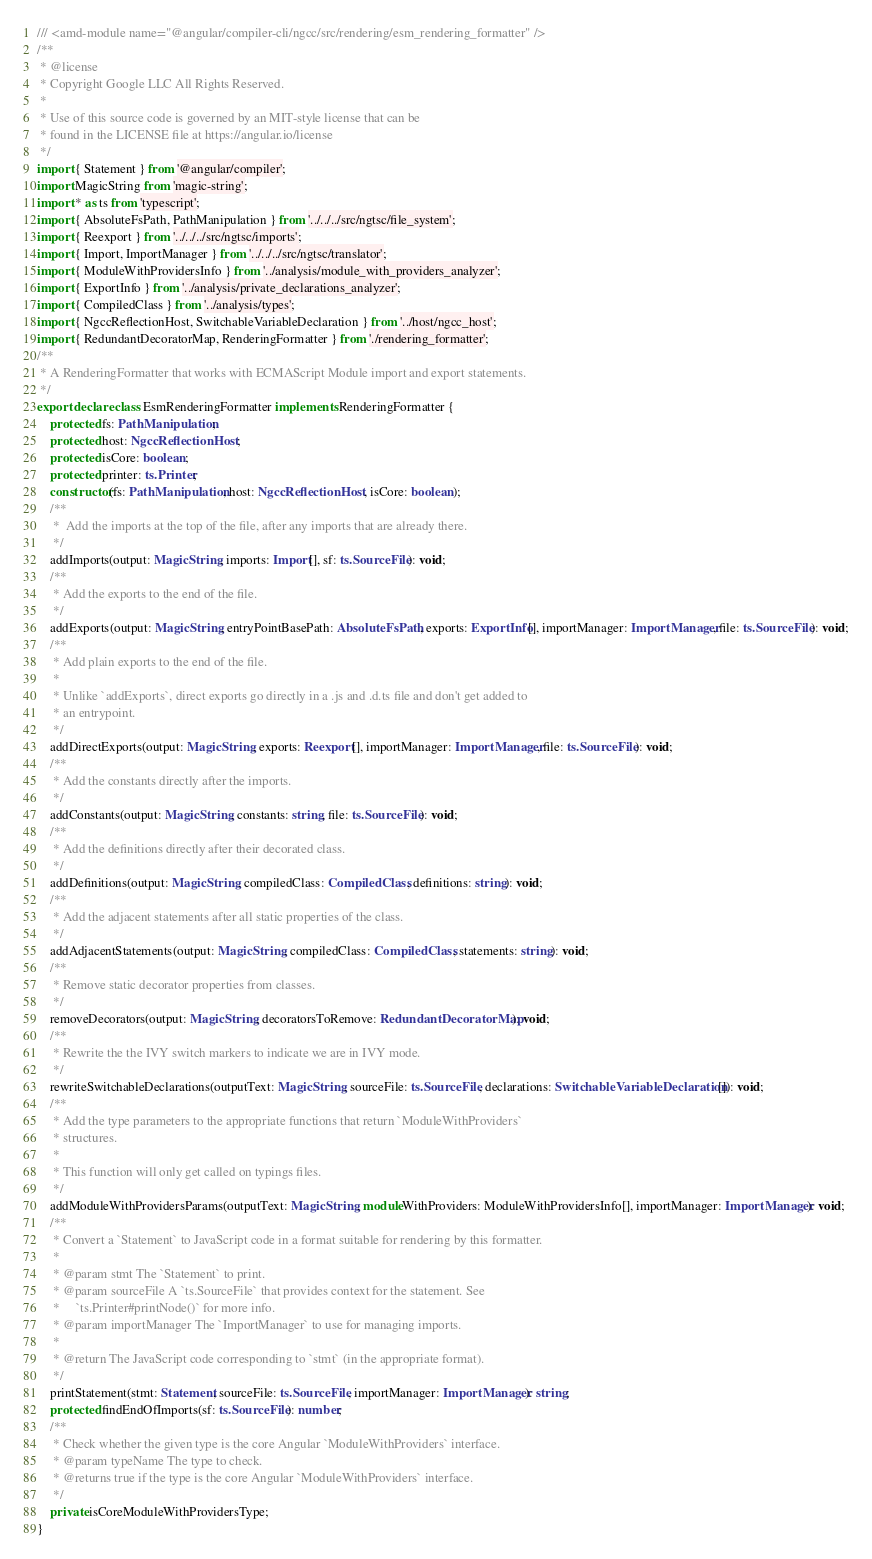<code> <loc_0><loc_0><loc_500><loc_500><_TypeScript_>/// <amd-module name="@angular/compiler-cli/ngcc/src/rendering/esm_rendering_formatter" />
/**
 * @license
 * Copyright Google LLC All Rights Reserved.
 *
 * Use of this source code is governed by an MIT-style license that can be
 * found in the LICENSE file at https://angular.io/license
 */
import { Statement } from '@angular/compiler';
import MagicString from 'magic-string';
import * as ts from 'typescript';
import { AbsoluteFsPath, PathManipulation } from '../../../src/ngtsc/file_system';
import { Reexport } from '../../../src/ngtsc/imports';
import { Import, ImportManager } from '../../../src/ngtsc/translator';
import { ModuleWithProvidersInfo } from '../analysis/module_with_providers_analyzer';
import { ExportInfo } from '../analysis/private_declarations_analyzer';
import { CompiledClass } from '../analysis/types';
import { NgccReflectionHost, SwitchableVariableDeclaration } from '../host/ngcc_host';
import { RedundantDecoratorMap, RenderingFormatter } from './rendering_formatter';
/**
 * A RenderingFormatter that works with ECMAScript Module import and export statements.
 */
export declare class EsmRenderingFormatter implements RenderingFormatter {
    protected fs: PathManipulation;
    protected host: NgccReflectionHost;
    protected isCore: boolean;
    protected printer: ts.Printer;
    constructor(fs: PathManipulation, host: NgccReflectionHost, isCore: boolean);
    /**
     *  Add the imports at the top of the file, after any imports that are already there.
     */
    addImports(output: MagicString, imports: Import[], sf: ts.SourceFile): void;
    /**
     * Add the exports to the end of the file.
     */
    addExports(output: MagicString, entryPointBasePath: AbsoluteFsPath, exports: ExportInfo[], importManager: ImportManager, file: ts.SourceFile): void;
    /**
     * Add plain exports to the end of the file.
     *
     * Unlike `addExports`, direct exports go directly in a .js and .d.ts file and don't get added to
     * an entrypoint.
     */
    addDirectExports(output: MagicString, exports: Reexport[], importManager: ImportManager, file: ts.SourceFile): void;
    /**
     * Add the constants directly after the imports.
     */
    addConstants(output: MagicString, constants: string, file: ts.SourceFile): void;
    /**
     * Add the definitions directly after their decorated class.
     */
    addDefinitions(output: MagicString, compiledClass: CompiledClass, definitions: string): void;
    /**
     * Add the adjacent statements after all static properties of the class.
     */
    addAdjacentStatements(output: MagicString, compiledClass: CompiledClass, statements: string): void;
    /**
     * Remove static decorator properties from classes.
     */
    removeDecorators(output: MagicString, decoratorsToRemove: RedundantDecoratorMap): void;
    /**
     * Rewrite the the IVY switch markers to indicate we are in IVY mode.
     */
    rewriteSwitchableDeclarations(outputText: MagicString, sourceFile: ts.SourceFile, declarations: SwitchableVariableDeclaration[]): void;
    /**
     * Add the type parameters to the appropriate functions that return `ModuleWithProviders`
     * structures.
     *
     * This function will only get called on typings files.
     */
    addModuleWithProvidersParams(outputText: MagicString, moduleWithProviders: ModuleWithProvidersInfo[], importManager: ImportManager): void;
    /**
     * Convert a `Statement` to JavaScript code in a format suitable for rendering by this formatter.
     *
     * @param stmt The `Statement` to print.
     * @param sourceFile A `ts.SourceFile` that provides context for the statement. See
     *     `ts.Printer#printNode()` for more info.
     * @param importManager The `ImportManager` to use for managing imports.
     *
     * @return The JavaScript code corresponding to `stmt` (in the appropriate format).
     */
    printStatement(stmt: Statement, sourceFile: ts.SourceFile, importManager: ImportManager): string;
    protected findEndOfImports(sf: ts.SourceFile): number;
    /**
     * Check whether the given type is the core Angular `ModuleWithProviders` interface.
     * @param typeName The type to check.
     * @returns true if the type is the core Angular `ModuleWithProviders` interface.
     */
    private isCoreModuleWithProvidersType;
}
</code> 